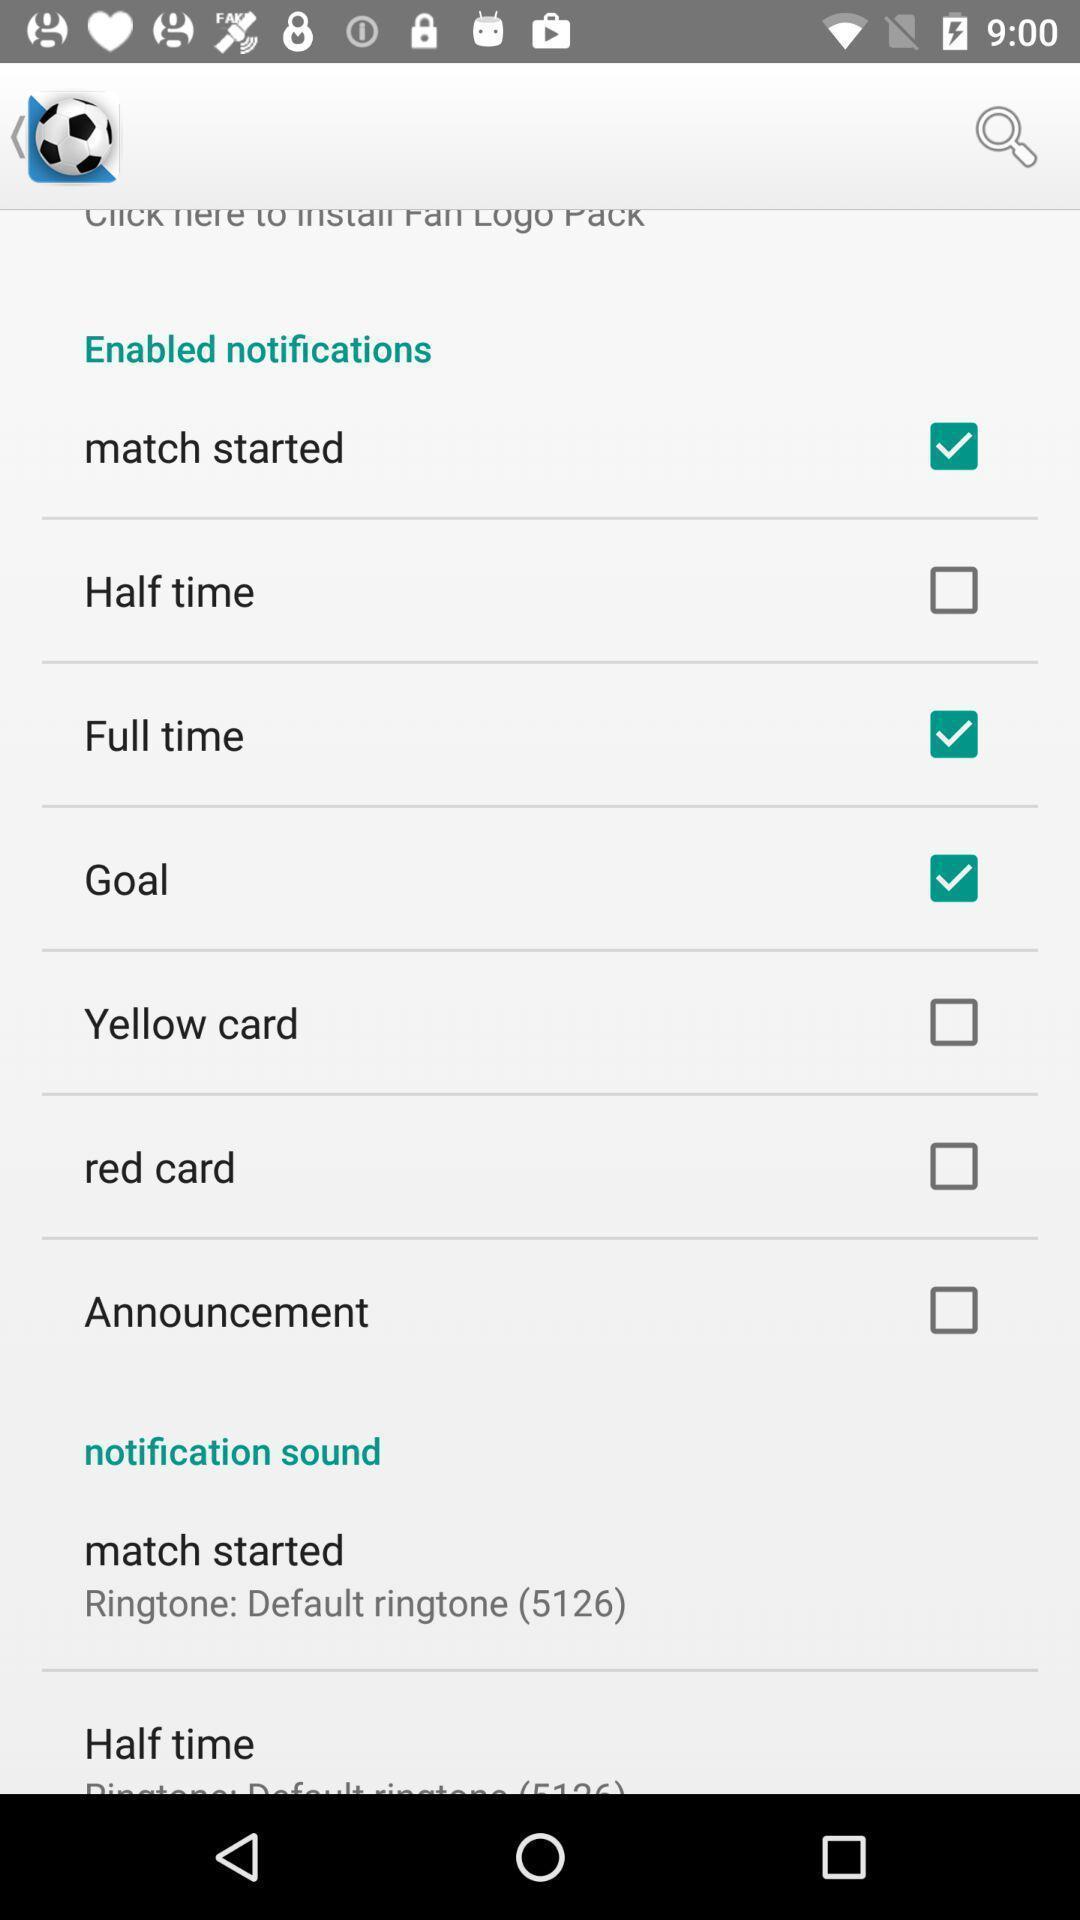Describe this image in words. Page displaying various notifications in a soccer app. 